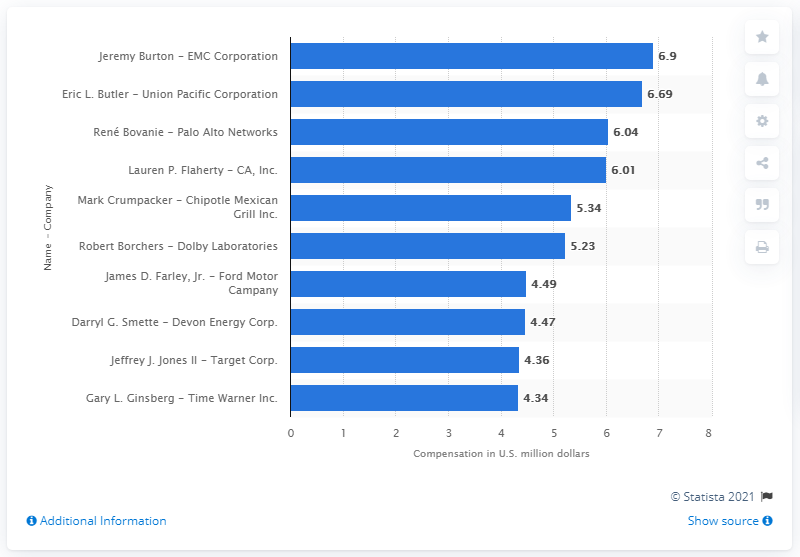Specify some key components in this picture. In 2014, Mark Crumpacker earned an amount of $5,341. 